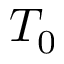Convert formula to latex. <formula><loc_0><loc_0><loc_500><loc_500>T _ { 0 }</formula> 